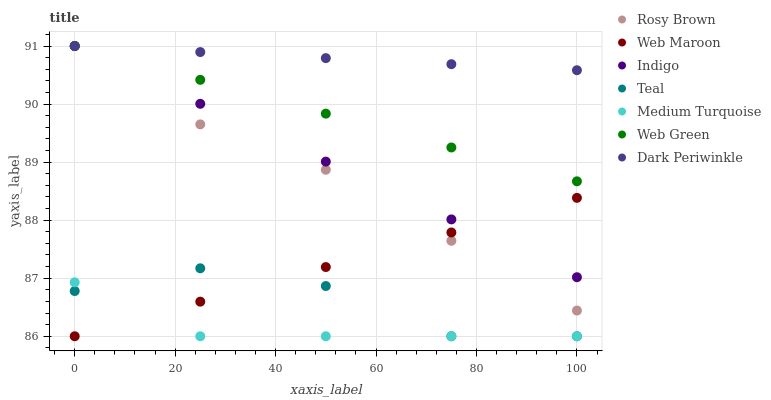Does Medium Turquoise have the minimum area under the curve?
Answer yes or no. Yes. Does Dark Periwinkle have the maximum area under the curve?
Answer yes or no. Yes. Does Teal have the minimum area under the curve?
Answer yes or no. No. Does Teal have the maximum area under the curve?
Answer yes or no. No. Is Dark Periwinkle the smoothest?
Answer yes or no. Yes. Is Teal the roughest?
Answer yes or no. Yes. Is Rosy Brown the smoothest?
Answer yes or no. No. Is Rosy Brown the roughest?
Answer yes or no. No. Does Teal have the lowest value?
Answer yes or no. Yes. Does Rosy Brown have the lowest value?
Answer yes or no. No. Does Dark Periwinkle have the highest value?
Answer yes or no. Yes. Does Teal have the highest value?
Answer yes or no. No. Is Medium Turquoise less than Indigo?
Answer yes or no. Yes. Is Indigo greater than Teal?
Answer yes or no. Yes. Does Dark Periwinkle intersect Indigo?
Answer yes or no. Yes. Is Dark Periwinkle less than Indigo?
Answer yes or no. No. Is Dark Periwinkle greater than Indigo?
Answer yes or no. No. Does Medium Turquoise intersect Indigo?
Answer yes or no. No. 